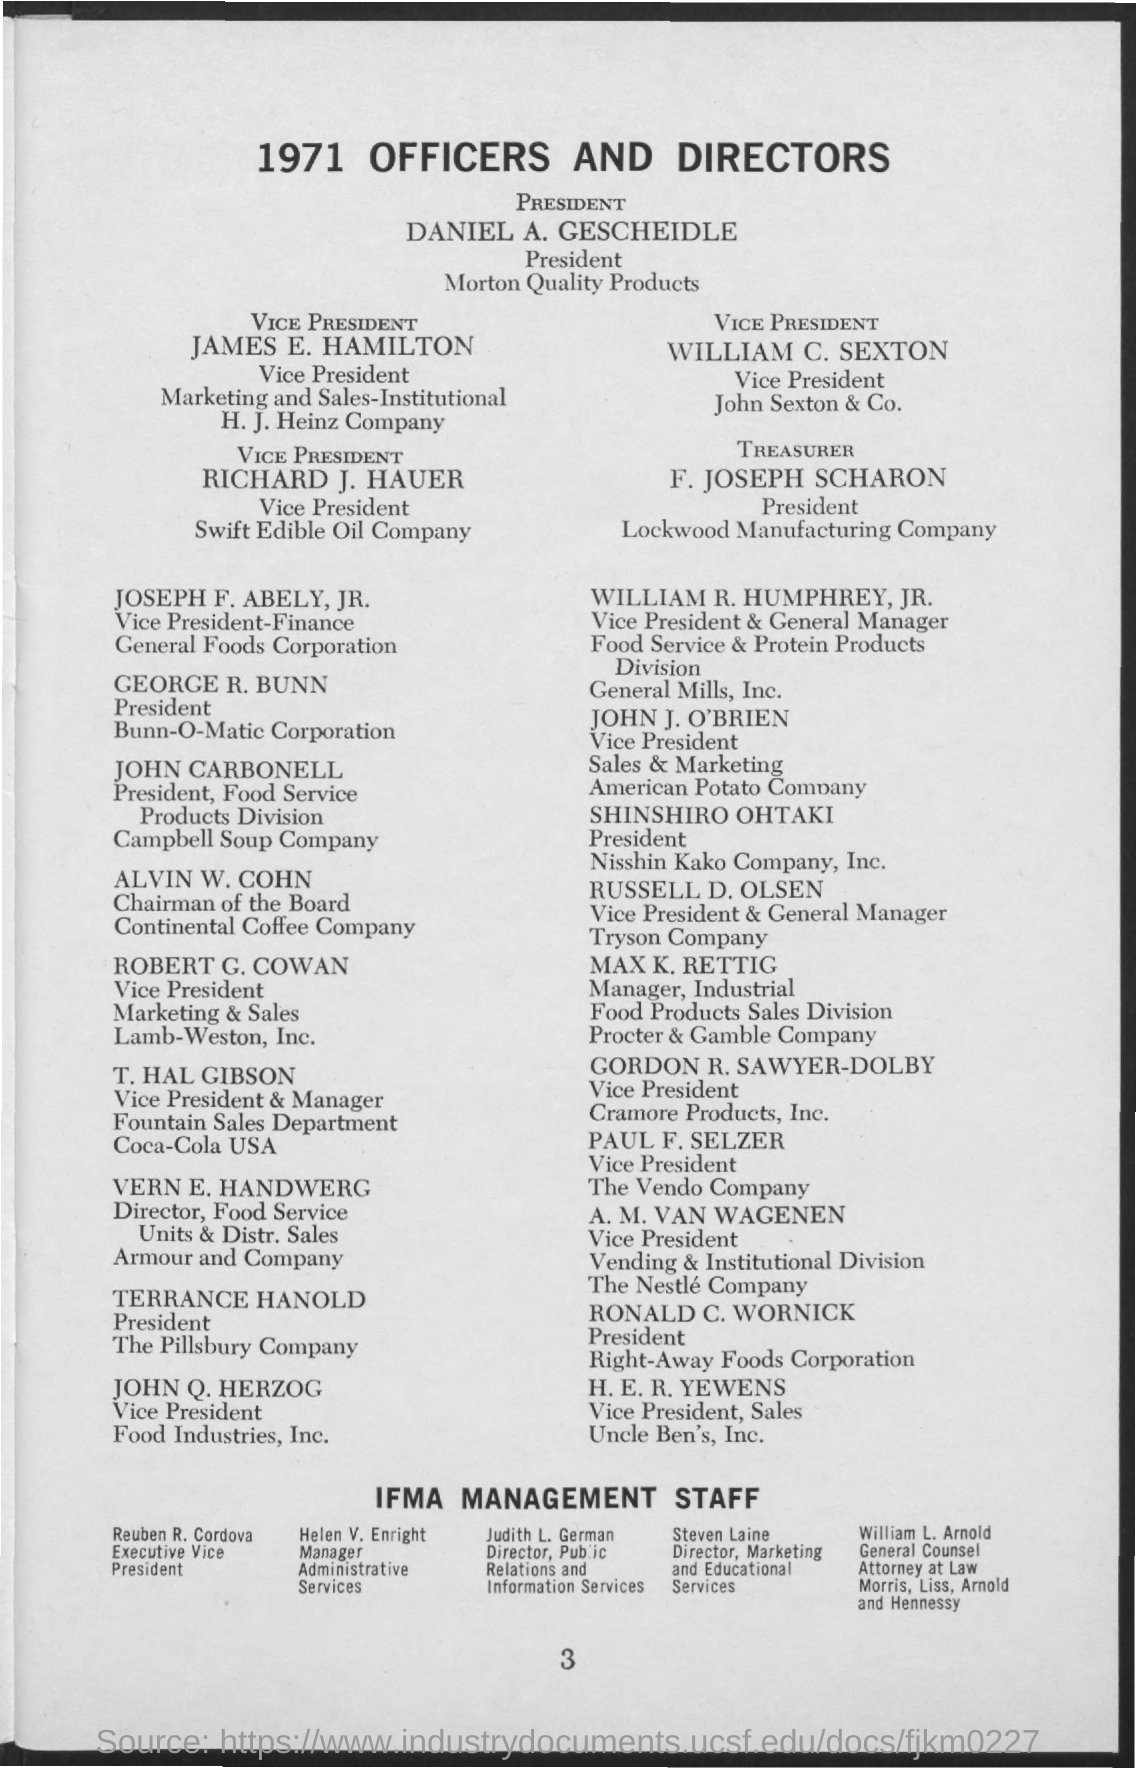What is the Title of the document?
Provide a succinct answer. 1971 OFFICERS AND DIRECTORS. 